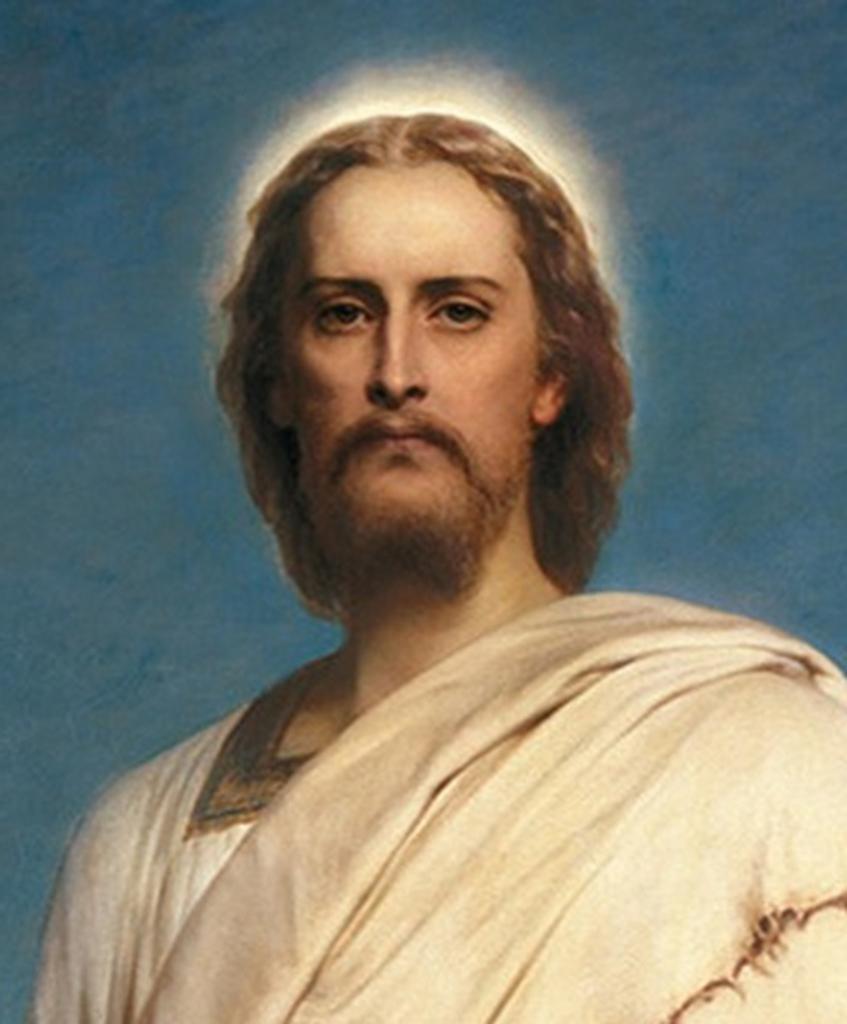Please provide a concise description of this image. In this image I can see depiction of a man in white dress. I can also see blue and white colour in background. 